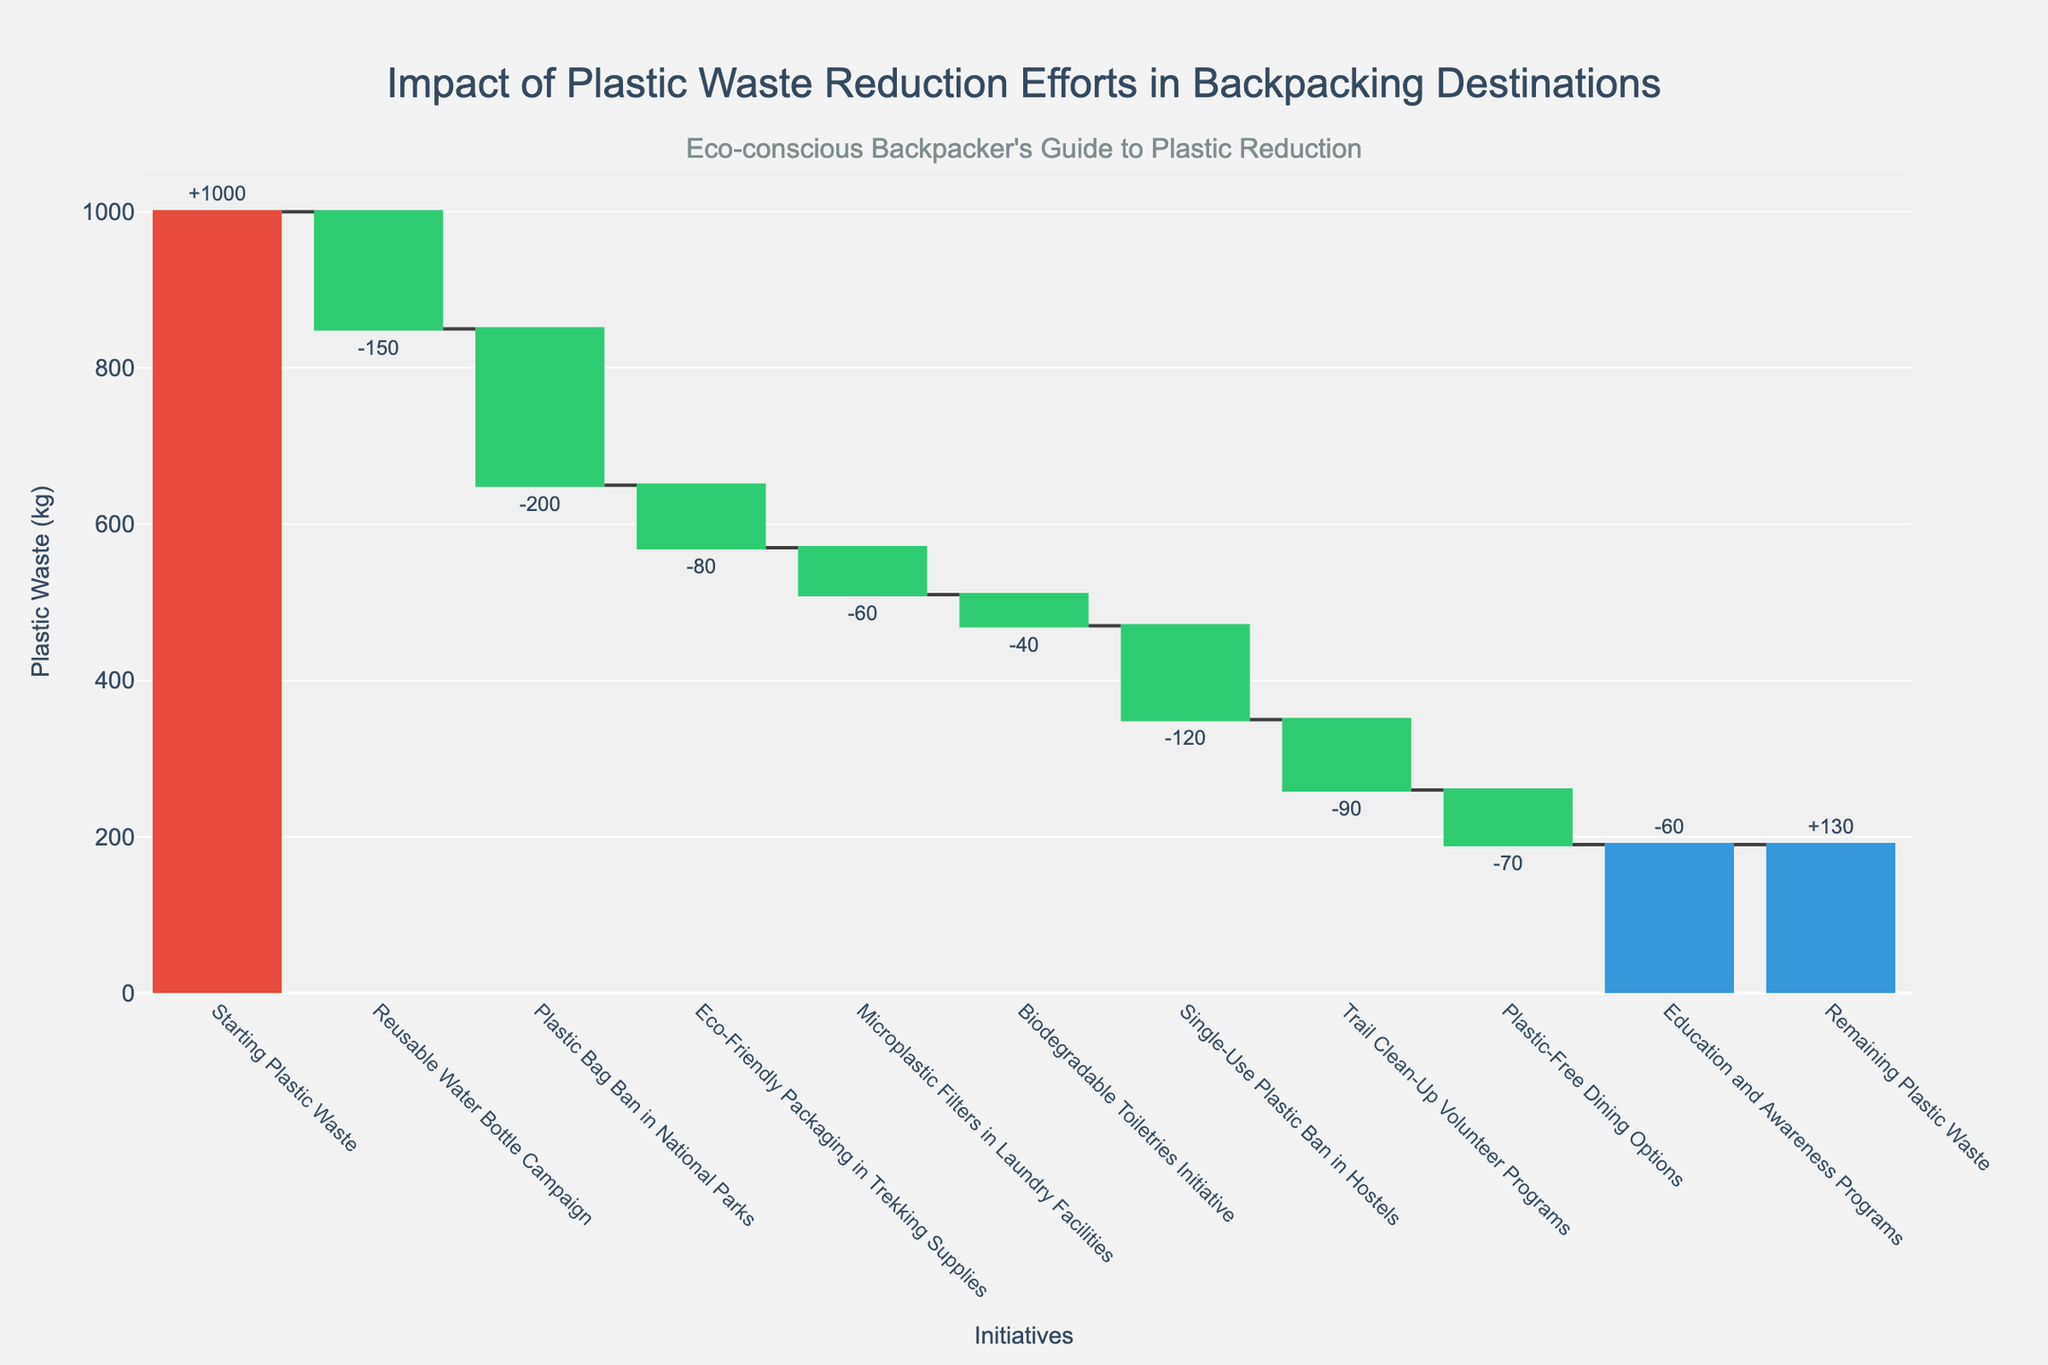What's the starting amount of plastic waste? The title and the first bar in the chart indicate the starting amount of plastic waste. The label on this bar reads "Starting Plastic Waste: 1000".
Answer: 1000 kg What's the impact of the reusable water bottle campaign on plastic waste reduction? The label associated with the "Reusable Water Bottle Campaign" bar shows a value of -150. This indicates a reduction in the plastic waste amount.
Answer: -150 kg Which initiative has the most significant impact on reducing plastic waste? By observing the values of each initiative, we can see that the "Plastic Bag Ban in National Parks" with a value of -200 has the largest reduction impact.
Answer: Plastic Bag Ban in National Parks What is the remaining plastic waste after all the reduction efforts? The final bar in the chart, labeled "Remaining Plastic Waste," indicates the amount of plastic waste after all efforts. The label shows 130.
Answer: 130 kg 